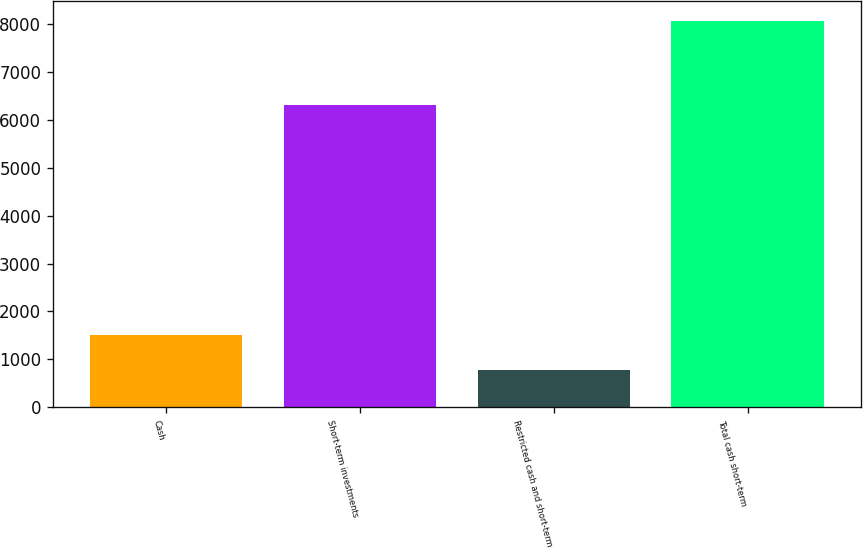Convert chart to OTSL. <chart><loc_0><loc_0><loc_500><loc_500><bar_chart><fcel>Cash<fcel>Short-term investments<fcel>Restricted cash and short-term<fcel>Total cash short-term<nl><fcel>1503<fcel>6306<fcel>774<fcel>8064<nl></chart> 